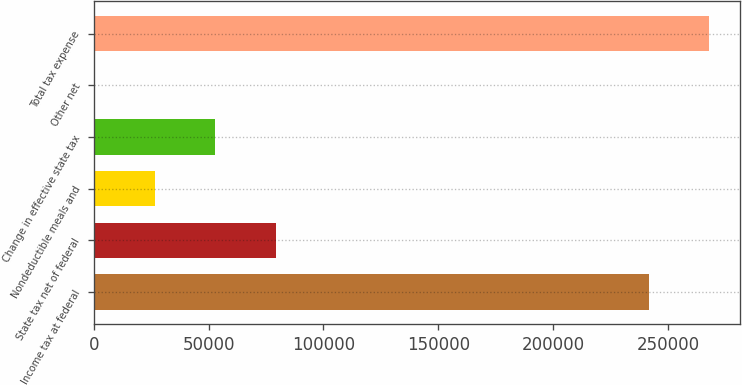<chart> <loc_0><loc_0><loc_500><loc_500><bar_chart><fcel>Income tax at federal<fcel>State tax net of federal<fcel>Nondeductible meals and<fcel>Change in effective state tax<fcel>Other net<fcel>Total tax expense<nl><fcel>241571<fcel>79208.9<fcel>26706.3<fcel>52957.6<fcel>455<fcel>267822<nl></chart> 